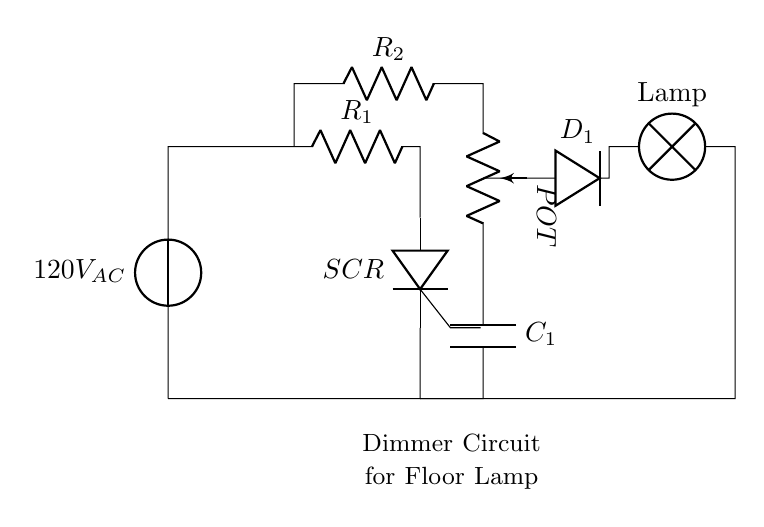What is the type of voltage source in this circuit? The circuit includes a voltage source labeled as 120V AC, indicating that it is an alternating current voltage source.
Answer: 120V AC What component is used to control the brightness of the lamp? The component that adjusts the brightness of the lamp is labeled as a potentiometer, which allows for adjustable resistance and therefore adjustable brightness.
Answer: Potentiometer How many resistors are present in this circuit? There are two resistors in the circuit diagram, identified as R1 and R2.
Answer: Two What does SCR stand for in this circuit? SCR stands for Silicon Controlled Rectifier, which is a semiconductor device used to control power.
Answer: Silicon Controlled Rectifier What is the function of capacitor C1 in the dimmer circuit? The capacitor C1 is typically used for filtering or smoothing the signal and can also help in controlling the timing of the SCR, contributing to the lamp's brightness control.
Answer: Filtering or smoothing What component is located after the diode in the circuit? After the diode D1, the next component in the circuit is the lamp, which is connected to the output for illumination.
Answer: Lamp What type of circuit is this? This circuit is a dimmer circuit, specifically designed to control the brightness of a floor lamp through adjustable resistance.
Answer: Dimmer circuit 